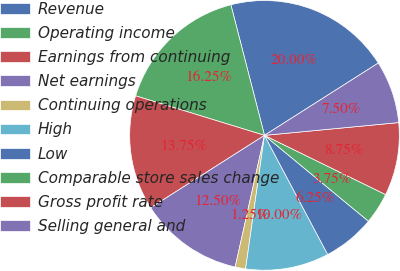Convert chart. <chart><loc_0><loc_0><loc_500><loc_500><pie_chart><fcel>Revenue<fcel>Operating income<fcel>Earnings from continuing<fcel>Net earnings<fcel>Continuing operations<fcel>High<fcel>Low<fcel>Comparable store sales change<fcel>Gross profit rate<fcel>Selling general and<nl><fcel>20.0%<fcel>16.25%<fcel>13.75%<fcel>12.5%<fcel>1.25%<fcel>10.0%<fcel>6.25%<fcel>3.75%<fcel>8.75%<fcel>7.5%<nl></chart> 